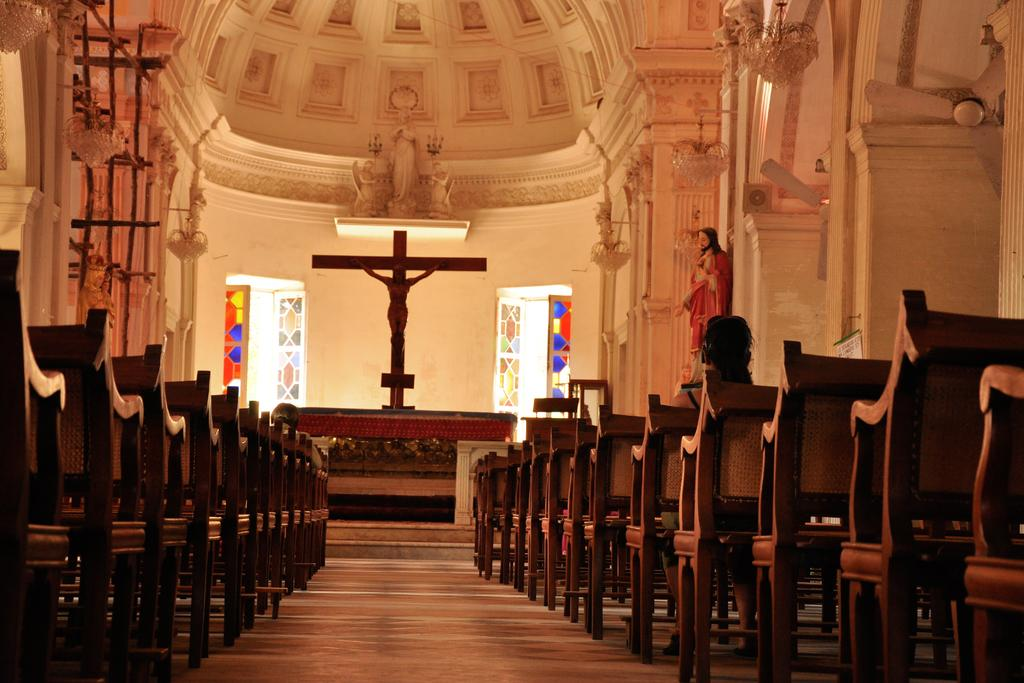What type of building is depicted in the image? The image shows the inside view of a church. What can be seen on the walls of the church? The church walls are visible in the image. What type of decorations are present in the church? Carved sculptures and statues are present in the church. What type of seating is available in the church? Chairs are present in the church. Where can the receipt for the church's renovation be found in the image? There is no receipt for the church's renovation present in the image. What type of shelf is used to store the church's books in the image? There is no shelf visible in the image; the focus is on the walls, decorations, and seating. 